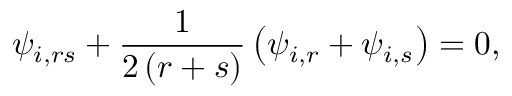<formula> <loc_0><loc_0><loc_500><loc_500>\psi _ { i , r s } + \frac { 1 } { 2 \left ( r + s \right ) } \left ( \psi _ { i , r } + \psi _ { i , s } \right ) = 0 ,</formula> 